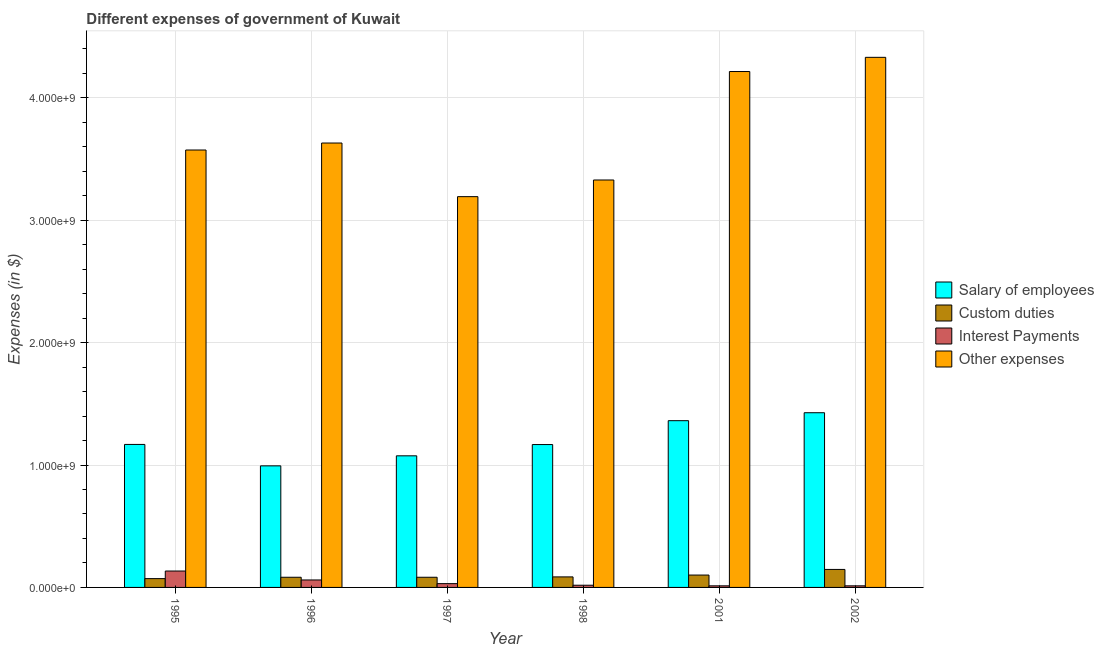How many different coloured bars are there?
Your response must be concise. 4. Are the number of bars on each tick of the X-axis equal?
Make the answer very short. Yes. How many bars are there on the 4th tick from the right?
Your answer should be very brief. 4. What is the label of the 1st group of bars from the left?
Make the answer very short. 1995. In how many cases, is the number of bars for a given year not equal to the number of legend labels?
Give a very brief answer. 0. What is the amount spent on salary of employees in 1996?
Provide a succinct answer. 9.93e+08. Across all years, what is the maximum amount spent on salary of employees?
Keep it short and to the point. 1.43e+09. Across all years, what is the minimum amount spent on interest payments?
Offer a terse response. 1.30e+07. What is the total amount spent on salary of employees in the graph?
Offer a terse response. 7.19e+09. What is the difference between the amount spent on custom duties in 1998 and that in 2001?
Keep it short and to the point. -1.50e+07. What is the difference between the amount spent on salary of employees in 1997 and the amount spent on custom duties in 1998?
Give a very brief answer. -9.20e+07. What is the average amount spent on interest payments per year?
Provide a short and direct response. 4.50e+07. What is the ratio of the amount spent on other expenses in 1996 to that in 1998?
Your answer should be very brief. 1.09. Is the amount spent on interest payments in 1995 less than that in 2001?
Make the answer very short. No. What is the difference between the highest and the second highest amount spent on other expenses?
Keep it short and to the point. 1.16e+08. What is the difference between the highest and the lowest amount spent on other expenses?
Ensure brevity in your answer.  1.14e+09. What does the 4th bar from the left in 1996 represents?
Your response must be concise. Other expenses. What does the 3rd bar from the right in 2002 represents?
Provide a short and direct response. Custom duties. How many bars are there?
Keep it short and to the point. 24. What is the difference between two consecutive major ticks on the Y-axis?
Offer a terse response. 1.00e+09. Does the graph contain any zero values?
Your response must be concise. No. How many legend labels are there?
Offer a terse response. 4. What is the title of the graph?
Your response must be concise. Different expenses of government of Kuwait. Does "Primary schools" appear as one of the legend labels in the graph?
Provide a succinct answer. No. What is the label or title of the Y-axis?
Make the answer very short. Expenses (in $). What is the Expenses (in $) of Salary of employees in 1995?
Provide a short and direct response. 1.17e+09. What is the Expenses (in $) in Custom duties in 1995?
Offer a very short reply. 7.20e+07. What is the Expenses (in $) of Interest Payments in 1995?
Offer a very short reply. 1.34e+08. What is the Expenses (in $) of Other expenses in 1995?
Ensure brevity in your answer.  3.57e+09. What is the Expenses (in $) in Salary of employees in 1996?
Ensure brevity in your answer.  9.93e+08. What is the Expenses (in $) of Custom duties in 1996?
Offer a terse response. 8.30e+07. What is the Expenses (in $) of Interest Payments in 1996?
Offer a very short reply. 6.10e+07. What is the Expenses (in $) of Other expenses in 1996?
Keep it short and to the point. 3.63e+09. What is the Expenses (in $) of Salary of employees in 1997?
Make the answer very short. 1.08e+09. What is the Expenses (in $) in Custom duties in 1997?
Provide a short and direct response. 8.30e+07. What is the Expenses (in $) of Interest Payments in 1997?
Your answer should be compact. 3.10e+07. What is the Expenses (in $) of Other expenses in 1997?
Your response must be concise. 3.19e+09. What is the Expenses (in $) in Salary of employees in 1998?
Make the answer very short. 1.17e+09. What is the Expenses (in $) in Custom duties in 1998?
Make the answer very short. 8.60e+07. What is the Expenses (in $) of Interest Payments in 1998?
Keep it short and to the point. 1.80e+07. What is the Expenses (in $) of Other expenses in 1998?
Ensure brevity in your answer.  3.33e+09. What is the Expenses (in $) of Salary of employees in 2001?
Provide a short and direct response. 1.36e+09. What is the Expenses (in $) of Custom duties in 2001?
Your answer should be very brief. 1.01e+08. What is the Expenses (in $) in Interest Payments in 2001?
Your answer should be compact. 1.30e+07. What is the Expenses (in $) in Other expenses in 2001?
Your answer should be compact. 4.21e+09. What is the Expenses (in $) of Salary of employees in 2002?
Your answer should be compact. 1.43e+09. What is the Expenses (in $) of Custom duties in 2002?
Give a very brief answer. 1.47e+08. What is the Expenses (in $) of Interest Payments in 2002?
Your answer should be very brief. 1.30e+07. What is the Expenses (in $) of Other expenses in 2002?
Give a very brief answer. 4.33e+09. Across all years, what is the maximum Expenses (in $) in Salary of employees?
Your answer should be very brief. 1.43e+09. Across all years, what is the maximum Expenses (in $) of Custom duties?
Your answer should be compact. 1.47e+08. Across all years, what is the maximum Expenses (in $) of Interest Payments?
Provide a succinct answer. 1.34e+08. Across all years, what is the maximum Expenses (in $) of Other expenses?
Ensure brevity in your answer.  4.33e+09. Across all years, what is the minimum Expenses (in $) in Salary of employees?
Make the answer very short. 9.93e+08. Across all years, what is the minimum Expenses (in $) of Custom duties?
Offer a very short reply. 7.20e+07. Across all years, what is the minimum Expenses (in $) in Interest Payments?
Keep it short and to the point. 1.30e+07. Across all years, what is the minimum Expenses (in $) of Other expenses?
Offer a very short reply. 3.19e+09. What is the total Expenses (in $) in Salary of employees in the graph?
Keep it short and to the point. 7.19e+09. What is the total Expenses (in $) in Custom duties in the graph?
Provide a short and direct response. 5.72e+08. What is the total Expenses (in $) of Interest Payments in the graph?
Your answer should be compact. 2.70e+08. What is the total Expenses (in $) in Other expenses in the graph?
Keep it short and to the point. 2.23e+1. What is the difference between the Expenses (in $) in Salary of employees in 1995 and that in 1996?
Your response must be concise. 1.75e+08. What is the difference between the Expenses (in $) in Custom duties in 1995 and that in 1996?
Your answer should be compact. -1.10e+07. What is the difference between the Expenses (in $) of Interest Payments in 1995 and that in 1996?
Offer a terse response. 7.30e+07. What is the difference between the Expenses (in $) of Other expenses in 1995 and that in 1996?
Offer a very short reply. -5.70e+07. What is the difference between the Expenses (in $) in Salary of employees in 1995 and that in 1997?
Your response must be concise. 9.30e+07. What is the difference between the Expenses (in $) of Custom duties in 1995 and that in 1997?
Your response must be concise. -1.10e+07. What is the difference between the Expenses (in $) of Interest Payments in 1995 and that in 1997?
Your answer should be compact. 1.03e+08. What is the difference between the Expenses (in $) of Other expenses in 1995 and that in 1997?
Provide a short and direct response. 3.81e+08. What is the difference between the Expenses (in $) of Custom duties in 1995 and that in 1998?
Your response must be concise. -1.40e+07. What is the difference between the Expenses (in $) of Interest Payments in 1995 and that in 1998?
Keep it short and to the point. 1.16e+08. What is the difference between the Expenses (in $) of Other expenses in 1995 and that in 1998?
Offer a terse response. 2.45e+08. What is the difference between the Expenses (in $) in Salary of employees in 1995 and that in 2001?
Offer a very short reply. -1.94e+08. What is the difference between the Expenses (in $) in Custom duties in 1995 and that in 2001?
Provide a succinct answer. -2.90e+07. What is the difference between the Expenses (in $) in Interest Payments in 1995 and that in 2001?
Make the answer very short. 1.21e+08. What is the difference between the Expenses (in $) of Other expenses in 1995 and that in 2001?
Your answer should be very brief. -6.41e+08. What is the difference between the Expenses (in $) in Salary of employees in 1995 and that in 2002?
Give a very brief answer. -2.59e+08. What is the difference between the Expenses (in $) of Custom duties in 1995 and that in 2002?
Offer a terse response. -7.50e+07. What is the difference between the Expenses (in $) of Interest Payments in 1995 and that in 2002?
Make the answer very short. 1.21e+08. What is the difference between the Expenses (in $) of Other expenses in 1995 and that in 2002?
Offer a very short reply. -7.57e+08. What is the difference between the Expenses (in $) in Salary of employees in 1996 and that in 1997?
Provide a short and direct response. -8.20e+07. What is the difference between the Expenses (in $) of Custom duties in 1996 and that in 1997?
Give a very brief answer. 0. What is the difference between the Expenses (in $) in Interest Payments in 1996 and that in 1997?
Keep it short and to the point. 3.00e+07. What is the difference between the Expenses (in $) of Other expenses in 1996 and that in 1997?
Ensure brevity in your answer.  4.38e+08. What is the difference between the Expenses (in $) in Salary of employees in 1996 and that in 1998?
Provide a succinct answer. -1.74e+08. What is the difference between the Expenses (in $) in Interest Payments in 1996 and that in 1998?
Ensure brevity in your answer.  4.30e+07. What is the difference between the Expenses (in $) of Other expenses in 1996 and that in 1998?
Your answer should be very brief. 3.02e+08. What is the difference between the Expenses (in $) of Salary of employees in 1996 and that in 2001?
Make the answer very short. -3.69e+08. What is the difference between the Expenses (in $) in Custom duties in 1996 and that in 2001?
Your answer should be very brief. -1.80e+07. What is the difference between the Expenses (in $) in Interest Payments in 1996 and that in 2001?
Your response must be concise. 4.80e+07. What is the difference between the Expenses (in $) of Other expenses in 1996 and that in 2001?
Your answer should be compact. -5.84e+08. What is the difference between the Expenses (in $) in Salary of employees in 1996 and that in 2002?
Make the answer very short. -4.34e+08. What is the difference between the Expenses (in $) in Custom duties in 1996 and that in 2002?
Offer a terse response. -6.40e+07. What is the difference between the Expenses (in $) in Interest Payments in 1996 and that in 2002?
Offer a terse response. 4.80e+07. What is the difference between the Expenses (in $) in Other expenses in 1996 and that in 2002?
Your response must be concise. -7.00e+08. What is the difference between the Expenses (in $) in Salary of employees in 1997 and that in 1998?
Offer a very short reply. -9.20e+07. What is the difference between the Expenses (in $) in Custom duties in 1997 and that in 1998?
Offer a very short reply. -3.00e+06. What is the difference between the Expenses (in $) in Interest Payments in 1997 and that in 1998?
Your response must be concise. 1.30e+07. What is the difference between the Expenses (in $) in Other expenses in 1997 and that in 1998?
Your answer should be very brief. -1.36e+08. What is the difference between the Expenses (in $) in Salary of employees in 1997 and that in 2001?
Make the answer very short. -2.87e+08. What is the difference between the Expenses (in $) of Custom duties in 1997 and that in 2001?
Make the answer very short. -1.80e+07. What is the difference between the Expenses (in $) in Interest Payments in 1997 and that in 2001?
Keep it short and to the point. 1.80e+07. What is the difference between the Expenses (in $) in Other expenses in 1997 and that in 2001?
Your answer should be very brief. -1.02e+09. What is the difference between the Expenses (in $) in Salary of employees in 1997 and that in 2002?
Offer a very short reply. -3.52e+08. What is the difference between the Expenses (in $) in Custom duties in 1997 and that in 2002?
Ensure brevity in your answer.  -6.40e+07. What is the difference between the Expenses (in $) of Interest Payments in 1997 and that in 2002?
Make the answer very short. 1.80e+07. What is the difference between the Expenses (in $) in Other expenses in 1997 and that in 2002?
Your answer should be very brief. -1.14e+09. What is the difference between the Expenses (in $) in Salary of employees in 1998 and that in 2001?
Ensure brevity in your answer.  -1.95e+08. What is the difference between the Expenses (in $) of Custom duties in 1998 and that in 2001?
Provide a succinct answer. -1.50e+07. What is the difference between the Expenses (in $) of Interest Payments in 1998 and that in 2001?
Provide a short and direct response. 5.00e+06. What is the difference between the Expenses (in $) of Other expenses in 1998 and that in 2001?
Offer a terse response. -8.86e+08. What is the difference between the Expenses (in $) of Salary of employees in 1998 and that in 2002?
Offer a terse response. -2.60e+08. What is the difference between the Expenses (in $) of Custom duties in 1998 and that in 2002?
Your answer should be very brief. -6.10e+07. What is the difference between the Expenses (in $) of Other expenses in 1998 and that in 2002?
Offer a terse response. -1.00e+09. What is the difference between the Expenses (in $) of Salary of employees in 2001 and that in 2002?
Your answer should be compact. -6.50e+07. What is the difference between the Expenses (in $) in Custom duties in 2001 and that in 2002?
Provide a short and direct response. -4.60e+07. What is the difference between the Expenses (in $) of Interest Payments in 2001 and that in 2002?
Ensure brevity in your answer.  0. What is the difference between the Expenses (in $) of Other expenses in 2001 and that in 2002?
Your answer should be very brief. -1.16e+08. What is the difference between the Expenses (in $) in Salary of employees in 1995 and the Expenses (in $) in Custom duties in 1996?
Your response must be concise. 1.08e+09. What is the difference between the Expenses (in $) in Salary of employees in 1995 and the Expenses (in $) in Interest Payments in 1996?
Keep it short and to the point. 1.11e+09. What is the difference between the Expenses (in $) of Salary of employees in 1995 and the Expenses (in $) of Other expenses in 1996?
Make the answer very short. -2.46e+09. What is the difference between the Expenses (in $) in Custom duties in 1995 and the Expenses (in $) in Interest Payments in 1996?
Ensure brevity in your answer.  1.10e+07. What is the difference between the Expenses (in $) in Custom duties in 1995 and the Expenses (in $) in Other expenses in 1996?
Make the answer very short. -3.56e+09. What is the difference between the Expenses (in $) in Interest Payments in 1995 and the Expenses (in $) in Other expenses in 1996?
Provide a short and direct response. -3.50e+09. What is the difference between the Expenses (in $) of Salary of employees in 1995 and the Expenses (in $) of Custom duties in 1997?
Make the answer very short. 1.08e+09. What is the difference between the Expenses (in $) of Salary of employees in 1995 and the Expenses (in $) of Interest Payments in 1997?
Make the answer very short. 1.14e+09. What is the difference between the Expenses (in $) in Salary of employees in 1995 and the Expenses (in $) in Other expenses in 1997?
Your answer should be compact. -2.02e+09. What is the difference between the Expenses (in $) of Custom duties in 1995 and the Expenses (in $) of Interest Payments in 1997?
Offer a terse response. 4.10e+07. What is the difference between the Expenses (in $) in Custom duties in 1995 and the Expenses (in $) in Other expenses in 1997?
Offer a terse response. -3.12e+09. What is the difference between the Expenses (in $) of Interest Payments in 1995 and the Expenses (in $) of Other expenses in 1997?
Your response must be concise. -3.06e+09. What is the difference between the Expenses (in $) of Salary of employees in 1995 and the Expenses (in $) of Custom duties in 1998?
Your answer should be compact. 1.08e+09. What is the difference between the Expenses (in $) in Salary of employees in 1995 and the Expenses (in $) in Interest Payments in 1998?
Provide a short and direct response. 1.15e+09. What is the difference between the Expenses (in $) of Salary of employees in 1995 and the Expenses (in $) of Other expenses in 1998?
Give a very brief answer. -2.16e+09. What is the difference between the Expenses (in $) in Custom duties in 1995 and the Expenses (in $) in Interest Payments in 1998?
Provide a succinct answer. 5.40e+07. What is the difference between the Expenses (in $) of Custom duties in 1995 and the Expenses (in $) of Other expenses in 1998?
Your answer should be compact. -3.26e+09. What is the difference between the Expenses (in $) in Interest Payments in 1995 and the Expenses (in $) in Other expenses in 1998?
Provide a succinct answer. -3.19e+09. What is the difference between the Expenses (in $) of Salary of employees in 1995 and the Expenses (in $) of Custom duties in 2001?
Provide a succinct answer. 1.07e+09. What is the difference between the Expenses (in $) in Salary of employees in 1995 and the Expenses (in $) in Interest Payments in 2001?
Ensure brevity in your answer.  1.16e+09. What is the difference between the Expenses (in $) in Salary of employees in 1995 and the Expenses (in $) in Other expenses in 2001?
Your response must be concise. -3.05e+09. What is the difference between the Expenses (in $) in Custom duties in 1995 and the Expenses (in $) in Interest Payments in 2001?
Offer a very short reply. 5.90e+07. What is the difference between the Expenses (in $) of Custom duties in 1995 and the Expenses (in $) of Other expenses in 2001?
Provide a succinct answer. -4.14e+09. What is the difference between the Expenses (in $) of Interest Payments in 1995 and the Expenses (in $) of Other expenses in 2001?
Provide a short and direct response. -4.08e+09. What is the difference between the Expenses (in $) in Salary of employees in 1995 and the Expenses (in $) in Custom duties in 2002?
Provide a succinct answer. 1.02e+09. What is the difference between the Expenses (in $) of Salary of employees in 1995 and the Expenses (in $) of Interest Payments in 2002?
Your answer should be compact. 1.16e+09. What is the difference between the Expenses (in $) in Salary of employees in 1995 and the Expenses (in $) in Other expenses in 2002?
Offer a very short reply. -3.16e+09. What is the difference between the Expenses (in $) in Custom duties in 1995 and the Expenses (in $) in Interest Payments in 2002?
Offer a terse response. 5.90e+07. What is the difference between the Expenses (in $) in Custom duties in 1995 and the Expenses (in $) in Other expenses in 2002?
Keep it short and to the point. -4.26e+09. What is the difference between the Expenses (in $) in Interest Payments in 1995 and the Expenses (in $) in Other expenses in 2002?
Make the answer very short. -4.20e+09. What is the difference between the Expenses (in $) in Salary of employees in 1996 and the Expenses (in $) in Custom duties in 1997?
Give a very brief answer. 9.10e+08. What is the difference between the Expenses (in $) in Salary of employees in 1996 and the Expenses (in $) in Interest Payments in 1997?
Your response must be concise. 9.62e+08. What is the difference between the Expenses (in $) of Salary of employees in 1996 and the Expenses (in $) of Other expenses in 1997?
Offer a terse response. -2.20e+09. What is the difference between the Expenses (in $) of Custom duties in 1996 and the Expenses (in $) of Interest Payments in 1997?
Provide a short and direct response. 5.20e+07. What is the difference between the Expenses (in $) of Custom duties in 1996 and the Expenses (in $) of Other expenses in 1997?
Your answer should be very brief. -3.11e+09. What is the difference between the Expenses (in $) in Interest Payments in 1996 and the Expenses (in $) in Other expenses in 1997?
Your answer should be compact. -3.13e+09. What is the difference between the Expenses (in $) in Salary of employees in 1996 and the Expenses (in $) in Custom duties in 1998?
Offer a terse response. 9.07e+08. What is the difference between the Expenses (in $) in Salary of employees in 1996 and the Expenses (in $) in Interest Payments in 1998?
Make the answer very short. 9.75e+08. What is the difference between the Expenses (in $) in Salary of employees in 1996 and the Expenses (in $) in Other expenses in 1998?
Offer a terse response. -2.34e+09. What is the difference between the Expenses (in $) in Custom duties in 1996 and the Expenses (in $) in Interest Payments in 1998?
Provide a succinct answer. 6.50e+07. What is the difference between the Expenses (in $) of Custom duties in 1996 and the Expenses (in $) of Other expenses in 1998?
Keep it short and to the point. -3.24e+09. What is the difference between the Expenses (in $) in Interest Payments in 1996 and the Expenses (in $) in Other expenses in 1998?
Keep it short and to the point. -3.27e+09. What is the difference between the Expenses (in $) of Salary of employees in 1996 and the Expenses (in $) of Custom duties in 2001?
Your response must be concise. 8.92e+08. What is the difference between the Expenses (in $) in Salary of employees in 1996 and the Expenses (in $) in Interest Payments in 2001?
Keep it short and to the point. 9.80e+08. What is the difference between the Expenses (in $) in Salary of employees in 1996 and the Expenses (in $) in Other expenses in 2001?
Give a very brief answer. -3.22e+09. What is the difference between the Expenses (in $) in Custom duties in 1996 and the Expenses (in $) in Interest Payments in 2001?
Your answer should be compact. 7.00e+07. What is the difference between the Expenses (in $) in Custom duties in 1996 and the Expenses (in $) in Other expenses in 2001?
Give a very brief answer. -4.13e+09. What is the difference between the Expenses (in $) of Interest Payments in 1996 and the Expenses (in $) of Other expenses in 2001?
Provide a succinct answer. -4.15e+09. What is the difference between the Expenses (in $) in Salary of employees in 1996 and the Expenses (in $) in Custom duties in 2002?
Ensure brevity in your answer.  8.46e+08. What is the difference between the Expenses (in $) of Salary of employees in 1996 and the Expenses (in $) of Interest Payments in 2002?
Provide a succinct answer. 9.80e+08. What is the difference between the Expenses (in $) in Salary of employees in 1996 and the Expenses (in $) in Other expenses in 2002?
Keep it short and to the point. -3.34e+09. What is the difference between the Expenses (in $) of Custom duties in 1996 and the Expenses (in $) of Interest Payments in 2002?
Ensure brevity in your answer.  7.00e+07. What is the difference between the Expenses (in $) in Custom duties in 1996 and the Expenses (in $) in Other expenses in 2002?
Your response must be concise. -4.25e+09. What is the difference between the Expenses (in $) of Interest Payments in 1996 and the Expenses (in $) of Other expenses in 2002?
Offer a terse response. -4.27e+09. What is the difference between the Expenses (in $) in Salary of employees in 1997 and the Expenses (in $) in Custom duties in 1998?
Your answer should be very brief. 9.89e+08. What is the difference between the Expenses (in $) of Salary of employees in 1997 and the Expenses (in $) of Interest Payments in 1998?
Your answer should be very brief. 1.06e+09. What is the difference between the Expenses (in $) of Salary of employees in 1997 and the Expenses (in $) of Other expenses in 1998?
Make the answer very short. -2.25e+09. What is the difference between the Expenses (in $) of Custom duties in 1997 and the Expenses (in $) of Interest Payments in 1998?
Your answer should be compact. 6.50e+07. What is the difference between the Expenses (in $) of Custom duties in 1997 and the Expenses (in $) of Other expenses in 1998?
Provide a short and direct response. -3.24e+09. What is the difference between the Expenses (in $) in Interest Payments in 1997 and the Expenses (in $) in Other expenses in 1998?
Keep it short and to the point. -3.30e+09. What is the difference between the Expenses (in $) in Salary of employees in 1997 and the Expenses (in $) in Custom duties in 2001?
Keep it short and to the point. 9.74e+08. What is the difference between the Expenses (in $) of Salary of employees in 1997 and the Expenses (in $) of Interest Payments in 2001?
Ensure brevity in your answer.  1.06e+09. What is the difference between the Expenses (in $) in Salary of employees in 1997 and the Expenses (in $) in Other expenses in 2001?
Provide a succinct answer. -3.14e+09. What is the difference between the Expenses (in $) in Custom duties in 1997 and the Expenses (in $) in Interest Payments in 2001?
Keep it short and to the point. 7.00e+07. What is the difference between the Expenses (in $) in Custom duties in 1997 and the Expenses (in $) in Other expenses in 2001?
Ensure brevity in your answer.  -4.13e+09. What is the difference between the Expenses (in $) of Interest Payments in 1997 and the Expenses (in $) of Other expenses in 2001?
Offer a terse response. -4.18e+09. What is the difference between the Expenses (in $) of Salary of employees in 1997 and the Expenses (in $) of Custom duties in 2002?
Keep it short and to the point. 9.28e+08. What is the difference between the Expenses (in $) of Salary of employees in 1997 and the Expenses (in $) of Interest Payments in 2002?
Provide a succinct answer. 1.06e+09. What is the difference between the Expenses (in $) of Salary of employees in 1997 and the Expenses (in $) of Other expenses in 2002?
Provide a short and direct response. -3.26e+09. What is the difference between the Expenses (in $) in Custom duties in 1997 and the Expenses (in $) in Interest Payments in 2002?
Your answer should be compact. 7.00e+07. What is the difference between the Expenses (in $) of Custom duties in 1997 and the Expenses (in $) of Other expenses in 2002?
Your response must be concise. -4.25e+09. What is the difference between the Expenses (in $) of Interest Payments in 1997 and the Expenses (in $) of Other expenses in 2002?
Offer a terse response. -4.30e+09. What is the difference between the Expenses (in $) of Salary of employees in 1998 and the Expenses (in $) of Custom duties in 2001?
Your response must be concise. 1.07e+09. What is the difference between the Expenses (in $) of Salary of employees in 1998 and the Expenses (in $) of Interest Payments in 2001?
Offer a very short reply. 1.15e+09. What is the difference between the Expenses (in $) in Salary of employees in 1998 and the Expenses (in $) in Other expenses in 2001?
Provide a succinct answer. -3.05e+09. What is the difference between the Expenses (in $) of Custom duties in 1998 and the Expenses (in $) of Interest Payments in 2001?
Provide a succinct answer. 7.30e+07. What is the difference between the Expenses (in $) of Custom duties in 1998 and the Expenses (in $) of Other expenses in 2001?
Your response must be concise. -4.13e+09. What is the difference between the Expenses (in $) of Interest Payments in 1998 and the Expenses (in $) of Other expenses in 2001?
Your answer should be compact. -4.20e+09. What is the difference between the Expenses (in $) in Salary of employees in 1998 and the Expenses (in $) in Custom duties in 2002?
Give a very brief answer. 1.02e+09. What is the difference between the Expenses (in $) in Salary of employees in 1998 and the Expenses (in $) in Interest Payments in 2002?
Provide a succinct answer. 1.15e+09. What is the difference between the Expenses (in $) in Salary of employees in 1998 and the Expenses (in $) in Other expenses in 2002?
Your answer should be very brief. -3.16e+09. What is the difference between the Expenses (in $) of Custom duties in 1998 and the Expenses (in $) of Interest Payments in 2002?
Provide a short and direct response. 7.30e+07. What is the difference between the Expenses (in $) of Custom duties in 1998 and the Expenses (in $) of Other expenses in 2002?
Ensure brevity in your answer.  -4.24e+09. What is the difference between the Expenses (in $) of Interest Payments in 1998 and the Expenses (in $) of Other expenses in 2002?
Give a very brief answer. -4.31e+09. What is the difference between the Expenses (in $) in Salary of employees in 2001 and the Expenses (in $) in Custom duties in 2002?
Make the answer very short. 1.22e+09. What is the difference between the Expenses (in $) in Salary of employees in 2001 and the Expenses (in $) in Interest Payments in 2002?
Offer a very short reply. 1.35e+09. What is the difference between the Expenses (in $) of Salary of employees in 2001 and the Expenses (in $) of Other expenses in 2002?
Provide a short and direct response. -2.97e+09. What is the difference between the Expenses (in $) of Custom duties in 2001 and the Expenses (in $) of Interest Payments in 2002?
Keep it short and to the point. 8.80e+07. What is the difference between the Expenses (in $) of Custom duties in 2001 and the Expenses (in $) of Other expenses in 2002?
Your answer should be very brief. -4.23e+09. What is the difference between the Expenses (in $) in Interest Payments in 2001 and the Expenses (in $) in Other expenses in 2002?
Offer a terse response. -4.32e+09. What is the average Expenses (in $) in Salary of employees per year?
Your answer should be very brief. 1.20e+09. What is the average Expenses (in $) in Custom duties per year?
Keep it short and to the point. 9.53e+07. What is the average Expenses (in $) of Interest Payments per year?
Your answer should be compact. 4.50e+07. What is the average Expenses (in $) in Other expenses per year?
Provide a succinct answer. 3.71e+09. In the year 1995, what is the difference between the Expenses (in $) in Salary of employees and Expenses (in $) in Custom duties?
Give a very brief answer. 1.10e+09. In the year 1995, what is the difference between the Expenses (in $) in Salary of employees and Expenses (in $) in Interest Payments?
Provide a short and direct response. 1.03e+09. In the year 1995, what is the difference between the Expenses (in $) of Salary of employees and Expenses (in $) of Other expenses?
Offer a very short reply. -2.40e+09. In the year 1995, what is the difference between the Expenses (in $) in Custom duties and Expenses (in $) in Interest Payments?
Your answer should be very brief. -6.20e+07. In the year 1995, what is the difference between the Expenses (in $) in Custom duties and Expenses (in $) in Other expenses?
Offer a terse response. -3.50e+09. In the year 1995, what is the difference between the Expenses (in $) in Interest Payments and Expenses (in $) in Other expenses?
Provide a short and direct response. -3.44e+09. In the year 1996, what is the difference between the Expenses (in $) of Salary of employees and Expenses (in $) of Custom duties?
Provide a short and direct response. 9.10e+08. In the year 1996, what is the difference between the Expenses (in $) of Salary of employees and Expenses (in $) of Interest Payments?
Your answer should be very brief. 9.32e+08. In the year 1996, what is the difference between the Expenses (in $) in Salary of employees and Expenses (in $) in Other expenses?
Your answer should be very brief. -2.64e+09. In the year 1996, what is the difference between the Expenses (in $) in Custom duties and Expenses (in $) in Interest Payments?
Make the answer very short. 2.20e+07. In the year 1996, what is the difference between the Expenses (in $) of Custom duties and Expenses (in $) of Other expenses?
Offer a terse response. -3.55e+09. In the year 1996, what is the difference between the Expenses (in $) of Interest Payments and Expenses (in $) of Other expenses?
Make the answer very short. -3.57e+09. In the year 1997, what is the difference between the Expenses (in $) in Salary of employees and Expenses (in $) in Custom duties?
Your answer should be compact. 9.92e+08. In the year 1997, what is the difference between the Expenses (in $) in Salary of employees and Expenses (in $) in Interest Payments?
Make the answer very short. 1.04e+09. In the year 1997, what is the difference between the Expenses (in $) of Salary of employees and Expenses (in $) of Other expenses?
Ensure brevity in your answer.  -2.12e+09. In the year 1997, what is the difference between the Expenses (in $) in Custom duties and Expenses (in $) in Interest Payments?
Offer a very short reply. 5.20e+07. In the year 1997, what is the difference between the Expenses (in $) of Custom duties and Expenses (in $) of Other expenses?
Offer a very short reply. -3.11e+09. In the year 1997, what is the difference between the Expenses (in $) of Interest Payments and Expenses (in $) of Other expenses?
Offer a very short reply. -3.16e+09. In the year 1998, what is the difference between the Expenses (in $) in Salary of employees and Expenses (in $) in Custom duties?
Make the answer very short. 1.08e+09. In the year 1998, what is the difference between the Expenses (in $) in Salary of employees and Expenses (in $) in Interest Payments?
Make the answer very short. 1.15e+09. In the year 1998, what is the difference between the Expenses (in $) of Salary of employees and Expenses (in $) of Other expenses?
Your answer should be very brief. -2.16e+09. In the year 1998, what is the difference between the Expenses (in $) in Custom duties and Expenses (in $) in Interest Payments?
Offer a terse response. 6.80e+07. In the year 1998, what is the difference between the Expenses (in $) in Custom duties and Expenses (in $) in Other expenses?
Offer a very short reply. -3.24e+09. In the year 1998, what is the difference between the Expenses (in $) of Interest Payments and Expenses (in $) of Other expenses?
Offer a terse response. -3.31e+09. In the year 2001, what is the difference between the Expenses (in $) of Salary of employees and Expenses (in $) of Custom duties?
Offer a terse response. 1.26e+09. In the year 2001, what is the difference between the Expenses (in $) of Salary of employees and Expenses (in $) of Interest Payments?
Provide a short and direct response. 1.35e+09. In the year 2001, what is the difference between the Expenses (in $) of Salary of employees and Expenses (in $) of Other expenses?
Provide a succinct answer. -2.85e+09. In the year 2001, what is the difference between the Expenses (in $) of Custom duties and Expenses (in $) of Interest Payments?
Provide a succinct answer. 8.80e+07. In the year 2001, what is the difference between the Expenses (in $) of Custom duties and Expenses (in $) of Other expenses?
Your answer should be very brief. -4.11e+09. In the year 2001, what is the difference between the Expenses (in $) in Interest Payments and Expenses (in $) in Other expenses?
Offer a very short reply. -4.20e+09. In the year 2002, what is the difference between the Expenses (in $) of Salary of employees and Expenses (in $) of Custom duties?
Provide a succinct answer. 1.28e+09. In the year 2002, what is the difference between the Expenses (in $) in Salary of employees and Expenses (in $) in Interest Payments?
Your answer should be very brief. 1.41e+09. In the year 2002, what is the difference between the Expenses (in $) of Salary of employees and Expenses (in $) of Other expenses?
Your answer should be very brief. -2.90e+09. In the year 2002, what is the difference between the Expenses (in $) of Custom duties and Expenses (in $) of Interest Payments?
Ensure brevity in your answer.  1.34e+08. In the year 2002, what is the difference between the Expenses (in $) in Custom duties and Expenses (in $) in Other expenses?
Make the answer very short. -4.18e+09. In the year 2002, what is the difference between the Expenses (in $) in Interest Payments and Expenses (in $) in Other expenses?
Provide a succinct answer. -4.32e+09. What is the ratio of the Expenses (in $) of Salary of employees in 1995 to that in 1996?
Your response must be concise. 1.18. What is the ratio of the Expenses (in $) in Custom duties in 1995 to that in 1996?
Give a very brief answer. 0.87. What is the ratio of the Expenses (in $) in Interest Payments in 1995 to that in 1996?
Ensure brevity in your answer.  2.2. What is the ratio of the Expenses (in $) in Other expenses in 1995 to that in 1996?
Your answer should be very brief. 0.98. What is the ratio of the Expenses (in $) of Salary of employees in 1995 to that in 1997?
Give a very brief answer. 1.09. What is the ratio of the Expenses (in $) of Custom duties in 1995 to that in 1997?
Give a very brief answer. 0.87. What is the ratio of the Expenses (in $) in Interest Payments in 1995 to that in 1997?
Your answer should be compact. 4.32. What is the ratio of the Expenses (in $) in Other expenses in 1995 to that in 1997?
Give a very brief answer. 1.12. What is the ratio of the Expenses (in $) of Salary of employees in 1995 to that in 1998?
Provide a short and direct response. 1. What is the ratio of the Expenses (in $) in Custom duties in 1995 to that in 1998?
Your response must be concise. 0.84. What is the ratio of the Expenses (in $) of Interest Payments in 1995 to that in 1998?
Ensure brevity in your answer.  7.44. What is the ratio of the Expenses (in $) in Other expenses in 1995 to that in 1998?
Make the answer very short. 1.07. What is the ratio of the Expenses (in $) of Salary of employees in 1995 to that in 2001?
Keep it short and to the point. 0.86. What is the ratio of the Expenses (in $) in Custom duties in 1995 to that in 2001?
Your answer should be very brief. 0.71. What is the ratio of the Expenses (in $) of Interest Payments in 1995 to that in 2001?
Provide a short and direct response. 10.31. What is the ratio of the Expenses (in $) of Other expenses in 1995 to that in 2001?
Give a very brief answer. 0.85. What is the ratio of the Expenses (in $) of Salary of employees in 1995 to that in 2002?
Make the answer very short. 0.82. What is the ratio of the Expenses (in $) in Custom duties in 1995 to that in 2002?
Offer a very short reply. 0.49. What is the ratio of the Expenses (in $) in Interest Payments in 1995 to that in 2002?
Offer a terse response. 10.31. What is the ratio of the Expenses (in $) of Other expenses in 1995 to that in 2002?
Ensure brevity in your answer.  0.83. What is the ratio of the Expenses (in $) in Salary of employees in 1996 to that in 1997?
Offer a terse response. 0.92. What is the ratio of the Expenses (in $) in Custom duties in 1996 to that in 1997?
Your response must be concise. 1. What is the ratio of the Expenses (in $) in Interest Payments in 1996 to that in 1997?
Offer a terse response. 1.97. What is the ratio of the Expenses (in $) in Other expenses in 1996 to that in 1997?
Ensure brevity in your answer.  1.14. What is the ratio of the Expenses (in $) in Salary of employees in 1996 to that in 1998?
Offer a very short reply. 0.85. What is the ratio of the Expenses (in $) in Custom duties in 1996 to that in 1998?
Give a very brief answer. 0.97. What is the ratio of the Expenses (in $) of Interest Payments in 1996 to that in 1998?
Give a very brief answer. 3.39. What is the ratio of the Expenses (in $) in Other expenses in 1996 to that in 1998?
Your answer should be very brief. 1.09. What is the ratio of the Expenses (in $) of Salary of employees in 1996 to that in 2001?
Your answer should be compact. 0.73. What is the ratio of the Expenses (in $) in Custom duties in 1996 to that in 2001?
Give a very brief answer. 0.82. What is the ratio of the Expenses (in $) in Interest Payments in 1996 to that in 2001?
Provide a succinct answer. 4.69. What is the ratio of the Expenses (in $) of Other expenses in 1996 to that in 2001?
Your answer should be compact. 0.86. What is the ratio of the Expenses (in $) of Salary of employees in 1996 to that in 2002?
Ensure brevity in your answer.  0.7. What is the ratio of the Expenses (in $) in Custom duties in 1996 to that in 2002?
Ensure brevity in your answer.  0.56. What is the ratio of the Expenses (in $) of Interest Payments in 1996 to that in 2002?
Your response must be concise. 4.69. What is the ratio of the Expenses (in $) of Other expenses in 1996 to that in 2002?
Your answer should be very brief. 0.84. What is the ratio of the Expenses (in $) of Salary of employees in 1997 to that in 1998?
Provide a succinct answer. 0.92. What is the ratio of the Expenses (in $) in Custom duties in 1997 to that in 1998?
Give a very brief answer. 0.97. What is the ratio of the Expenses (in $) in Interest Payments in 1997 to that in 1998?
Provide a short and direct response. 1.72. What is the ratio of the Expenses (in $) in Other expenses in 1997 to that in 1998?
Provide a succinct answer. 0.96. What is the ratio of the Expenses (in $) in Salary of employees in 1997 to that in 2001?
Your answer should be very brief. 0.79. What is the ratio of the Expenses (in $) in Custom duties in 1997 to that in 2001?
Ensure brevity in your answer.  0.82. What is the ratio of the Expenses (in $) of Interest Payments in 1997 to that in 2001?
Give a very brief answer. 2.38. What is the ratio of the Expenses (in $) of Other expenses in 1997 to that in 2001?
Make the answer very short. 0.76. What is the ratio of the Expenses (in $) in Salary of employees in 1997 to that in 2002?
Keep it short and to the point. 0.75. What is the ratio of the Expenses (in $) in Custom duties in 1997 to that in 2002?
Make the answer very short. 0.56. What is the ratio of the Expenses (in $) of Interest Payments in 1997 to that in 2002?
Make the answer very short. 2.38. What is the ratio of the Expenses (in $) in Other expenses in 1997 to that in 2002?
Offer a terse response. 0.74. What is the ratio of the Expenses (in $) in Salary of employees in 1998 to that in 2001?
Ensure brevity in your answer.  0.86. What is the ratio of the Expenses (in $) in Custom duties in 1998 to that in 2001?
Your answer should be compact. 0.85. What is the ratio of the Expenses (in $) of Interest Payments in 1998 to that in 2001?
Offer a very short reply. 1.38. What is the ratio of the Expenses (in $) in Other expenses in 1998 to that in 2001?
Provide a short and direct response. 0.79. What is the ratio of the Expenses (in $) of Salary of employees in 1998 to that in 2002?
Your answer should be very brief. 0.82. What is the ratio of the Expenses (in $) of Custom duties in 1998 to that in 2002?
Make the answer very short. 0.58. What is the ratio of the Expenses (in $) in Interest Payments in 1998 to that in 2002?
Your answer should be compact. 1.38. What is the ratio of the Expenses (in $) in Other expenses in 1998 to that in 2002?
Offer a very short reply. 0.77. What is the ratio of the Expenses (in $) of Salary of employees in 2001 to that in 2002?
Your answer should be compact. 0.95. What is the ratio of the Expenses (in $) in Custom duties in 2001 to that in 2002?
Offer a very short reply. 0.69. What is the ratio of the Expenses (in $) in Interest Payments in 2001 to that in 2002?
Your response must be concise. 1. What is the ratio of the Expenses (in $) in Other expenses in 2001 to that in 2002?
Ensure brevity in your answer.  0.97. What is the difference between the highest and the second highest Expenses (in $) in Salary of employees?
Offer a very short reply. 6.50e+07. What is the difference between the highest and the second highest Expenses (in $) in Custom duties?
Keep it short and to the point. 4.60e+07. What is the difference between the highest and the second highest Expenses (in $) in Interest Payments?
Your answer should be very brief. 7.30e+07. What is the difference between the highest and the second highest Expenses (in $) of Other expenses?
Provide a short and direct response. 1.16e+08. What is the difference between the highest and the lowest Expenses (in $) of Salary of employees?
Your response must be concise. 4.34e+08. What is the difference between the highest and the lowest Expenses (in $) in Custom duties?
Your answer should be very brief. 7.50e+07. What is the difference between the highest and the lowest Expenses (in $) in Interest Payments?
Keep it short and to the point. 1.21e+08. What is the difference between the highest and the lowest Expenses (in $) of Other expenses?
Make the answer very short. 1.14e+09. 